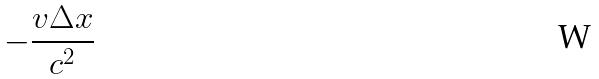<formula> <loc_0><loc_0><loc_500><loc_500>- \frac { v \Delta x } { c ^ { 2 } }</formula> 